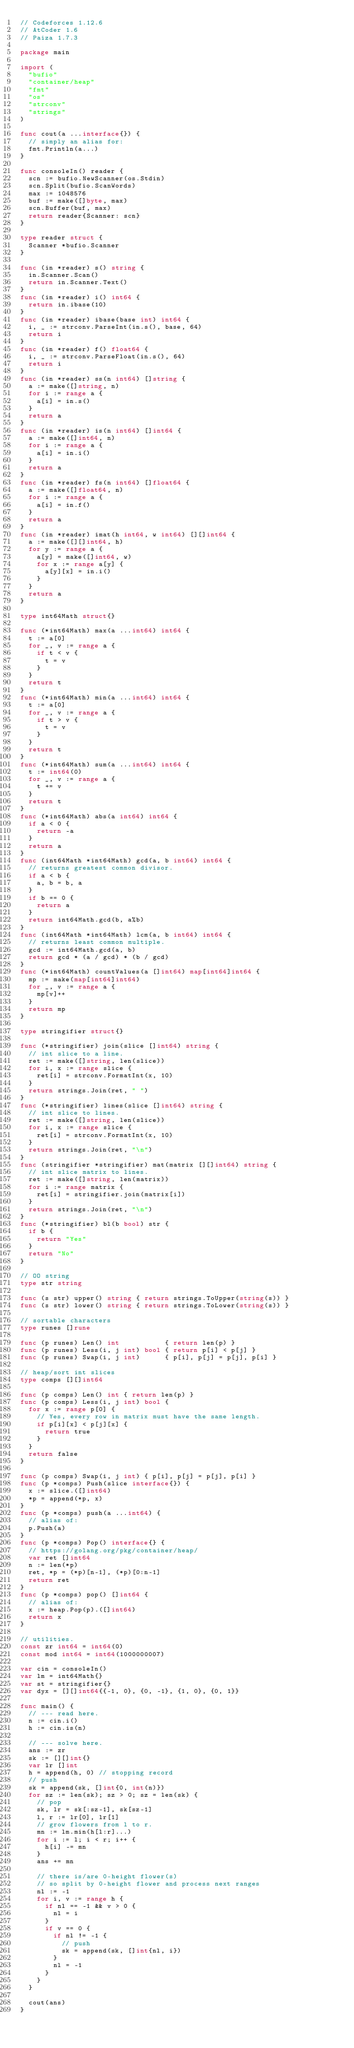Convert code to text. <code><loc_0><loc_0><loc_500><loc_500><_Go_>// Codeforces 1.12.6
// AtCoder 1.6
// Paiza 1.7.3

package main

import (
	"bufio"
	"container/heap"
	"fmt"
	"os"
	"strconv"
	"strings"
)

func cout(a ...interface{}) {
	// simply an alias for:
	fmt.Println(a...)
}

func consoleIn() reader {
	scn := bufio.NewScanner(os.Stdin)
	scn.Split(bufio.ScanWords)
	max := 1048576
	buf := make([]byte, max)
	scn.Buffer(buf, max)
	return reader{Scanner: scn}
}

type reader struct {
	Scanner *bufio.Scanner
}

func (in *reader) s() string {
	in.Scanner.Scan()
	return in.Scanner.Text()
}
func (in *reader) i() int64 {
	return in.ibase(10)
}
func (in *reader) ibase(base int) int64 {
	i, _ := strconv.ParseInt(in.s(), base, 64)
	return i
}
func (in *reader) f() float64 {
	i, _ := strconv.ParseFloat(in.s(), 64)
	return i
}
func (in *reader) ss(n int64) []string {
	a := make([]string, n)
	for i := range a {
		a[i] = in.s()
	}
	return a
}
func (in *reader) is(n int64) []int64 {
	a := make([]int64, n)
	for i := range a {
		a[i] = in.i()
	}
	return a
}
func (in *reader) fs(n int64) []float64 {
	a := make([]float64, n)
	for i := range a {
		a[i] = in.f()
	}
	return a
}
func (in *reader) imat(h int64, w int64) [][]int64 {
	a := make([][]int64, h)
	for y := range a {
		a[y] = make([]int64, w)
		for x := range a[y] {
			a[y][x] = in.i()
		}
	}
	return a
}

type int64Math struct{}

func (*int64Math) max(a ...int64) int64 {
	t := a[0]
	for _, v := range a {
		if t < v {
			t = v
		}
	}
	return t
}
func (*int64Math) min(a ...int64) int64 {
	t := a[0]
	for _, v := range a {
		if t > v {
			t = v
		}
	}
	return t
}
func (*int64Math) sum(a ...int64) int64 {
	t := int64(0)
	for _, v := range a {
		t += v
	}
	return t
}
func (*int64Math) abs(a int64) int64 {
	if a < 0 {
		return -a
	}
	return a
}
func (int64Math *int64Math) gcd(a, b int64) int64 {
	// returns greatest common divisor.
	if a < b {
		a, b = b, a
	}
	if b == 0 {
		return a
	}
	return int64Math.gcd(b, a%b)
}
func (int64Math *int64Math) lcm(a, b int64) int64 {
	// returns least common multiple.
	gcd := int64Math.gcd(a, b)
	return gcd * (a / gcd) * (b / gcd)
}
func (*int64Math) countValues(a []int64) map[int64]int64 {
	mp := make(map[int64]int64)
	for _, v := range a {
		mp[v]++
	}
	return mp
}

type stringifier struct{}

func (*stringifier) join(slice []int64) string {
	// int slice to a line.
	ret := make([]string, len(slice))
	for i, x := range slice {
		ret[i] = strconv.FormatInt(x, 10)
	}
	return strings.Join(ret, " ")
}
func (*stringifier) lines(slice []int64) string {
	// int slice to lines.
	ret := make([]string, len(slice))
	for i, x := range slice {
		ret[i] = strconv.FormatInt(x, 10)
	}
	return strings.Join(ret, "\n")
}
func (stringifier *stringifier) mat(matrix [][]int64) string {
	// int slice matrix to lines.
	ret := make([]string, len(matrix))
	for i := range matrix {
		ret[i] = stringifier.join(matrix[i])
	}
	return strings.Join(ret, "\n")
}
func (*stringifier) bl(b bool) str {
	if b {
		return "Yes"
	}
	return "No"
}

// OO string
type str string

func (s str) upper() string { return strings.ToUpper(string(s)) }
func (s str) lower() string { return strings.ToLower(string(s)) }

// sortable characters
type runes []rune

func (p runes) Len() int           { return len(p) }
func (p runes) Less(i, j int) bool { return p[i] < p[j] }
func (p runes) Swap(i, j int)      { p[i], p[j] = p[j], p[i] }

// heap/sort int slices
type comps [][]int64

func (p comps) Len() int { return len(p) }
func (p comps) Less(i, j int) bool {
	for x := range p[0] {
		// Yes, every row in matrix must have the same length.
		if p[i][x] < p[j][x] {
			return true
		}
	}
	return false
}

func (p comps) Swap(i, j int) { p[i], p[j] = p[j], p[i] }
func (p *comps) Push(slice interface{}) {
	x := slice.([]int64)
	*p = append(*p, x)
}
func (p *comps) push(a ...int64) {
	// alias of:
	p.Push(a)
}
func (p *comps) Pop() interface{} {
	// https://golang.org/pkg/container/heap/
	var ret []int64
	n := len(*p)
	ret, *p = (*p)[n-1], (*p)[0:n-1]
	return ret
}
func (p *comps) pop() []int64 {
	// alias of:
	x := heap.Pop(p).([]int64)
	return x
}

// utilities.
const zr int64 = int64(0)
const mod int64 = int64(1000000007)

var cin = consoleIn()
var lm = int64Math{}
var st = stringifier{}
var dyx = [][]int64{{-1, 0}, {0, -1}, {1, 0}, {0, 1}}

func main() {
	// --- read here.
	n := cin.i()
	h := cin.is(n)

	// --- solve here.
	ans := zr
	sk := [][]int{}
	var lr []int
	h = append(h, 0) // stopping record
	// push
	sk = append(sk, []int{0, int(n)})
	for sz := len(sk); sz > 0; sz = len(sk) {
		// pop
		sk, lr = sk[:sz-1], sk[sz-1]
		l, r := lr[0], lr[1]
		// grow flowers from l to r.
		mn := lm.min(h[l:r]...)
		for i := l; i < r; i++ {
			h[i] -= mn
		}
		ans += mn

		// there is/are 0-height flower(s)
		// so split by 0-height flower and process next ranges
		nl := -1
		for i, v := range h {
			if nl == -1 && v > 0 {
				nl = i
			}
			if v == 0 {
				if nl != -1 {
					// push
					sk = append(sk, []int{nl, i})
				}
				nl = -1
			}
		}
	}

	cout(ans)
}
</code> 